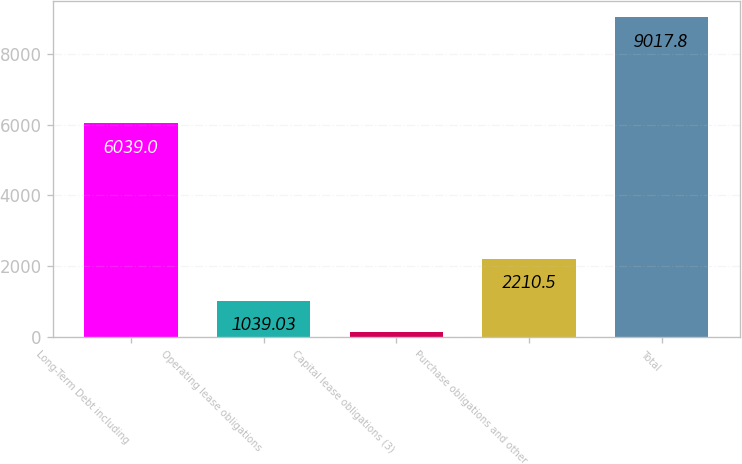Convert chart to OTSL. <chart><loc_0><loc_0><loc_500><loc_500><bar_chart><fcel>Long-Term Debt including<fcel>Operating lease obligations<fcel>Capital lease obligations (3)<fcel>Purchase obligations and other<fcel>Total<nl><fcel>6039<fcel>1039.03<fcel>152.5<fcel>2210.5<fcel>9017.8<nl></chart> 